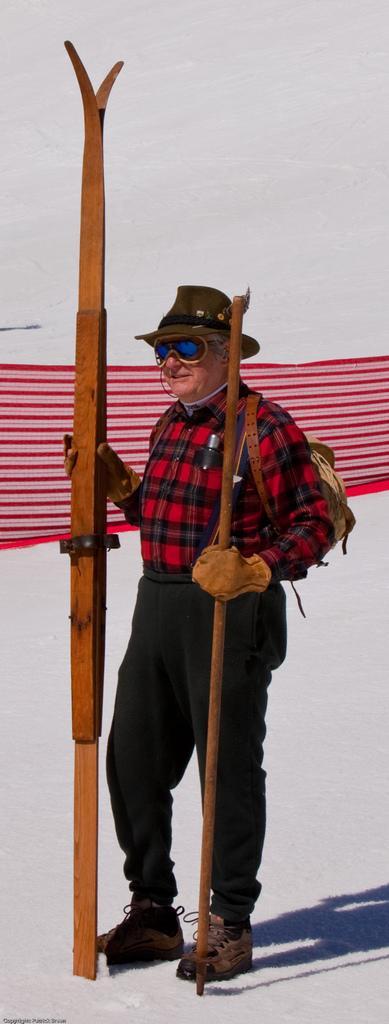Describe this image in one or two sentences. In the image we can see there is a man who is standing on the ground and the ground is covered with snow. The person is wearing goggles, that, the person is holding the wooden pole in his hand and he is carrying a backpack. 